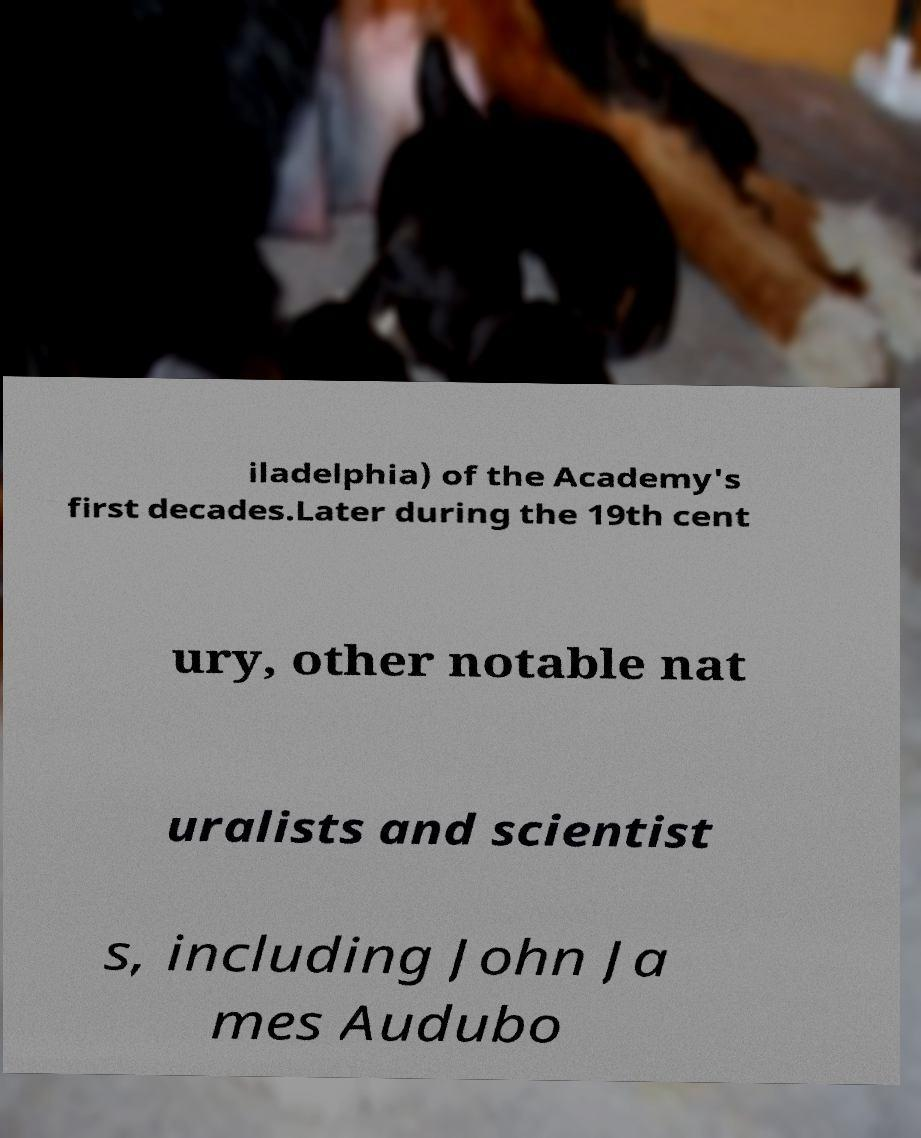I need the written content from this picture converted into text. Can you do that? iladelphia) of the Academy's first decades.Later during the 19th cent ury, other notable nat uralists and scientist s, including John Ja mes Audubo 